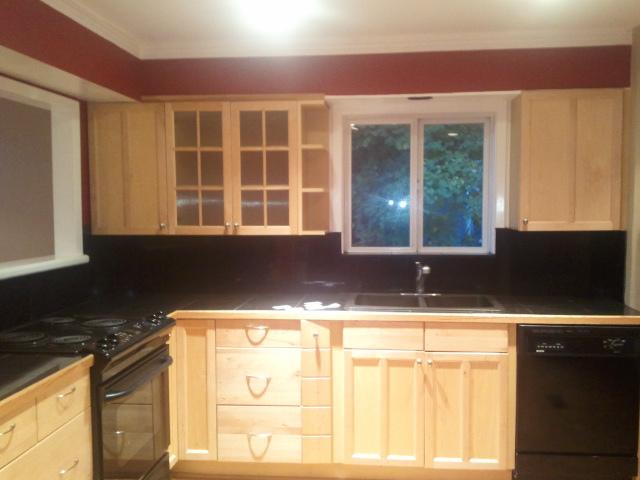What room is in the photo?
Concise answer only. Kitchen. Does it seem that this house is between owners?
Be succinct. Yes. Where is the sink located?
Quick response, please. Kitchen. Where is the glare in the picture?
Give a very brief answer. Window. 